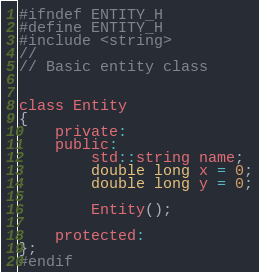Convert code to text. <code><loc_0><loc_0><loc_500><loc_500><_C_>#ifndef ENTITY_H
#define ENTITY_H
#include <string>
//
// Basic entity class


class Entity
{
    private:
    public:
        std::string name;
        double long x = 0;
        double long y = 0;

        Entity();

    protected:
};
#endif
</code> 